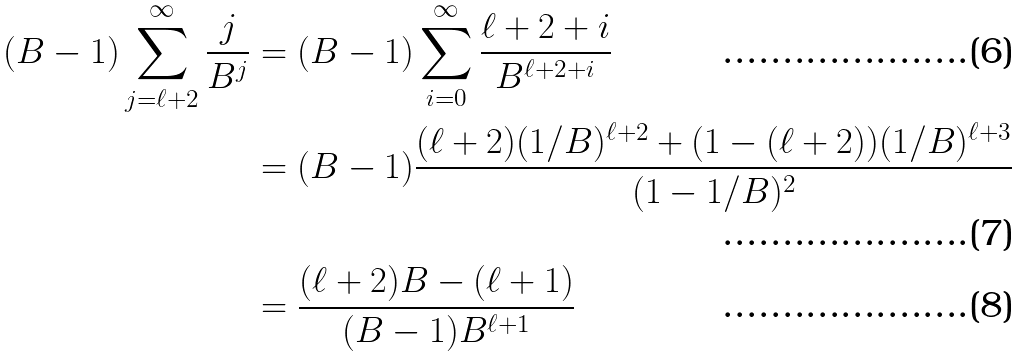Convert formula to latex. <formula><loc_0><loc_0><loc_500><loc_500>( B - 1 ) \sum _ { j = \ell + 2 } ^ { \infty } \frac { j } { B ^ { j } } & = ( B - 1 ) \sum _ { i = 0 } ^ { \infty } \frac { \ell + 2 + i } { B ^ { \ell + 2 + i } } \\ & = ( B - 1 ) \frac { ( \ell + 2 ) ( 1 / B ) ^ { \ell + 2 } + ( 1 - ( \ell + 2 ) ) ( 1 / B ) ^ { \ell + 3 } } { ( 1 - 1 / B ) ^ { 2 } } \\ & = \frac { ( \ell + 2 ) B - ( \ell + 1 ) } { ( B - 1 ) B ^ { \ell + 1 } }</formula> 